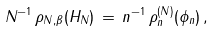<formula> <loc_0><loc_0><loc_500><loc_500>N ^ { - 1 } \, \rho _ { N , \beta } ( H _ { N } ) \, = \, n ^ { - 1 } \, \rho ^ { ( N ) } _ { n } ( \phi _ { n } ) \, ,</formula> 